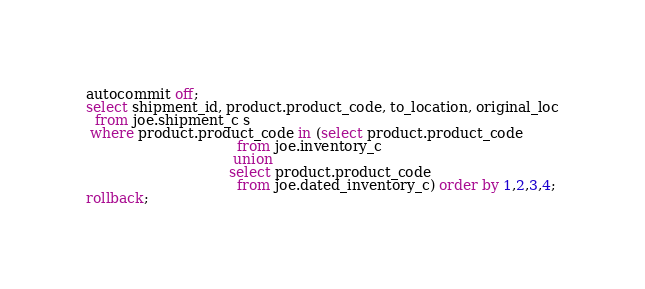<code> <loc_0><loc_0><loc_500><loc_500><_SQL_>autocommit off;
select shipment_id, product.product_code, to_location, original_loc
  from joe.shipment_c s
 where product.product_code in (select product.product_code
                                  from joe.inventory_c
                                 union
                                select product.product_code
                                  from joe.dated_inventory_c) order by 1,2,3,4;
rollback;
</code> 